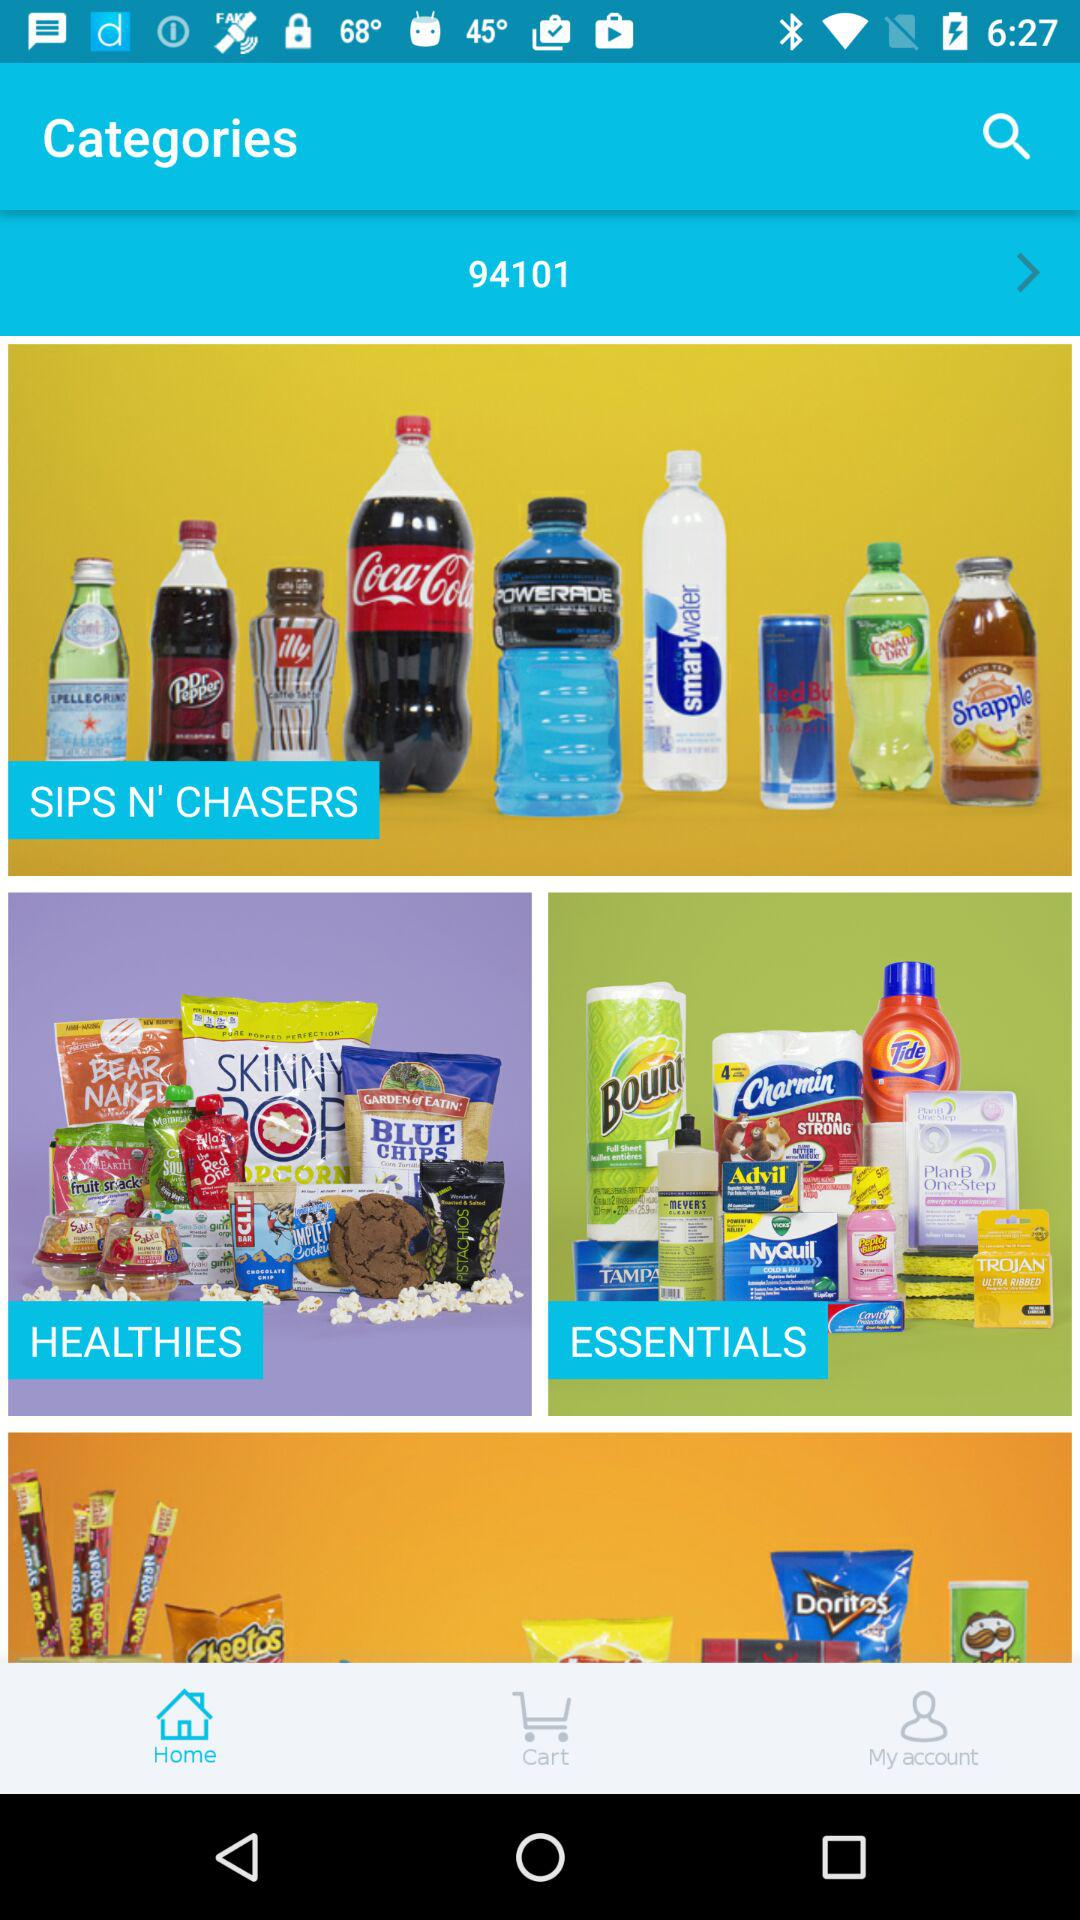Which city has the 94101 zip code?
When the provided information is insufficient, respond with <no answer>. <no answer> 